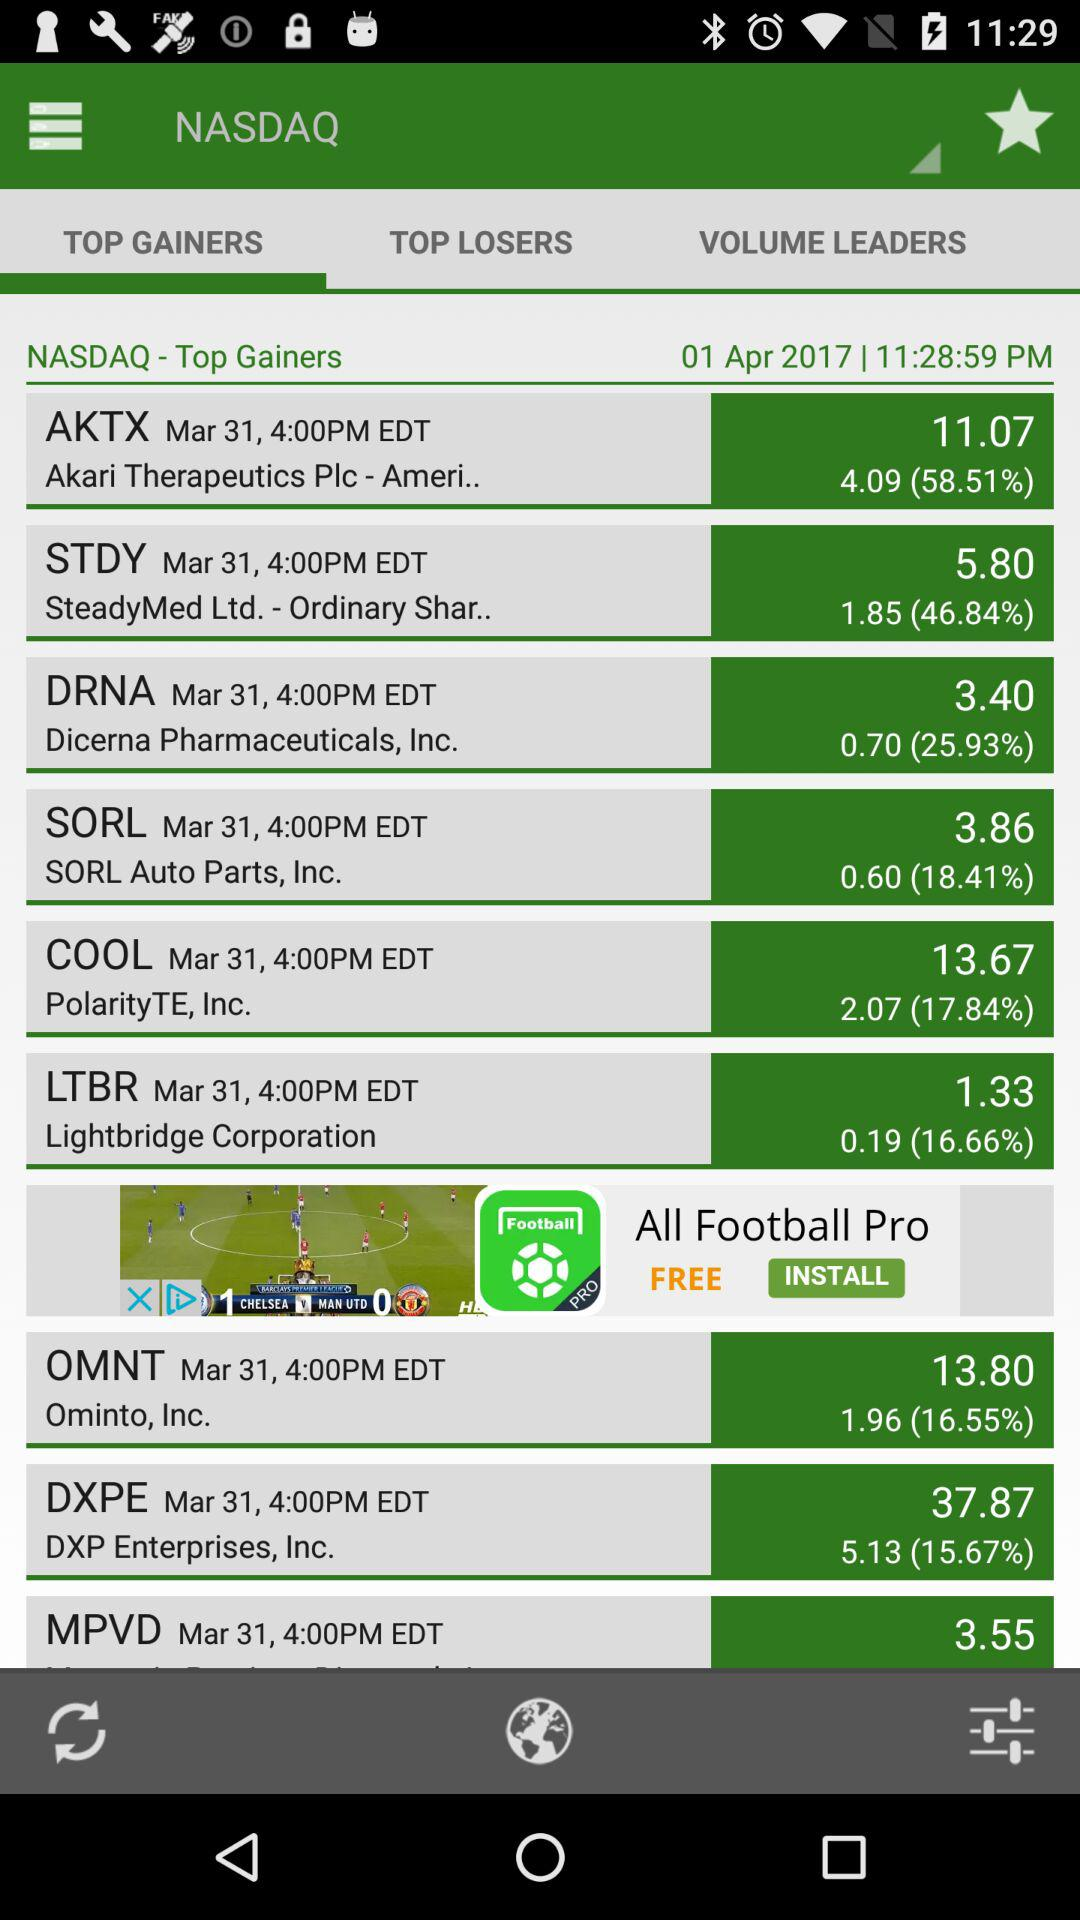What is the increased % of DRNA? The increased % of DRNA is 25.93. 